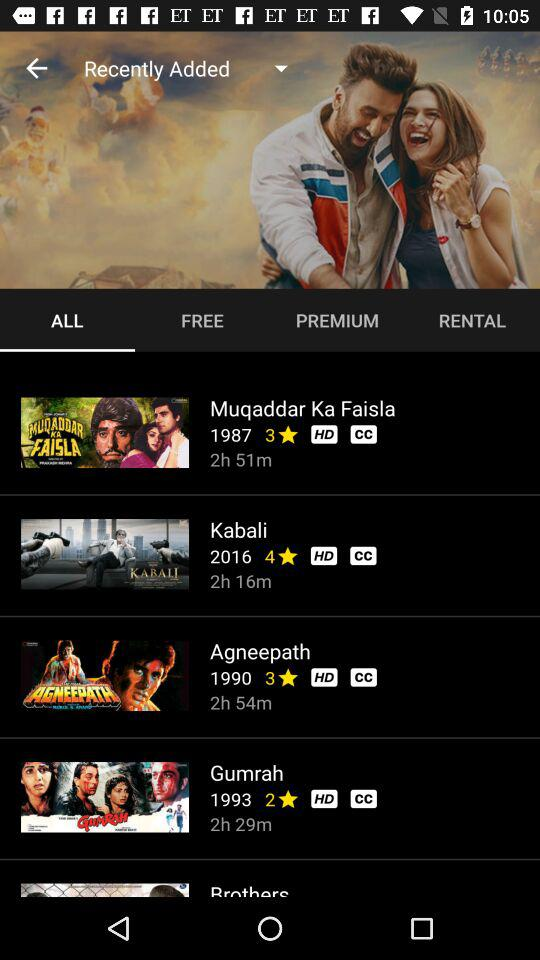How long is the movie "Kabali"? The movie "Kabali" is 2 hours 16 minutes long. 